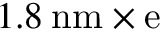Convert formula to latex. <formula><loc_0><loc_0><loc_500><loc_500>1 . 8 \, n m \times e</formula> 